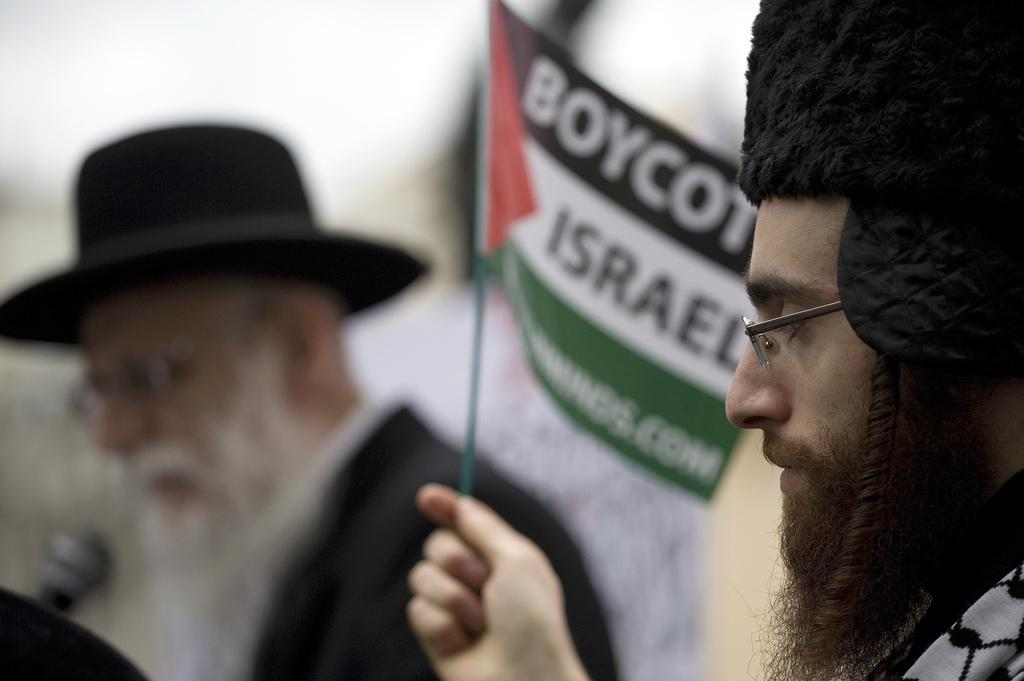What is the person in the image holding? The person in the image is holding a flag. Can you describe the background of the image? The background of the image is blurred. Are there any other people in the image besides the person holding the flag? Yes, there is at least one other person in the image. What object can be seen in the image that is typically used for amplifying sound? There is a microphone present in the image. What type of fish can be seen swimming in the background of the image? There are no fish present in the image; the background is blurred. 